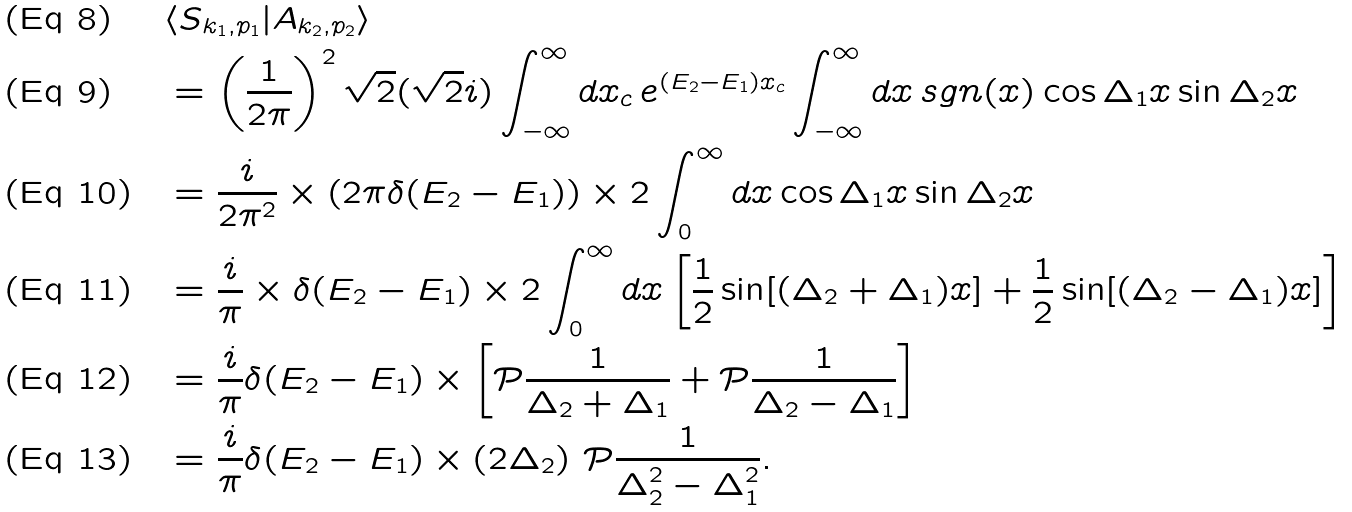Convert formula to latex. <formula><loc_0><loc_0><loc_500><loc_500>& \langle S _ { k _ { 1 } , p _ { 1 } } | A _ { k _ { 2 } , p _ { 2 } } \rangle \\ & = \left ( \frac { 1 } { 2 \pi } \right ) ^ { 2 } \sqrt { 2 } ( \sqrt { 2 } i ) \int _ { - \infty } ^ { \infty } d x _ { c } \, e ^ { ( E _ { 2 } - E _ { 1 } ) x _ { c } } \int _ { - \infty } ^ { \infty } d x \, s g n ( x ) \cos \Delta _ { 1 } x \sin \Delta _ { 2 } x \\ & = \frac { i } { 2 \pi ^ { 2 } } \times \left ( 2 \pi \delta ( E _ { 2 } - E _ { 1 } ) \right ) \times 2 \int _ { 0 } ^ { \infty } d x \cos \Delta _ { 1 } x \sin \Delta _ { 2 } x \\ & = \frac { i } { \pi } \times \delta ( E _ { 2 } - E _ { 1 } ) \times 2 \int _ { 0 } ^ { \infty } d x \left [ \frac { 1 } { 2 } \sin [ ( \Delta _ { 2 } + \Delta _ { 1 } ) x ] + \frac { 1 } { 2 } \sin [ ( \Delta _ { 2 } - \Delta _ { 1 } ) x ] \right ] \\ & = \frac { i } { \pi } \delta ( E _ { 2 } - E _ { 1 } ) \times \left [ \mathcal { P } \frac { 1 } { \Delta _ { 2 } + \Delta _ { 1 } } + \mathcal { P } \frac { 1 } { \Delta _ { 2 } - \Delta _ { 1 } } \right ] \\ & = \frac { i } { \pi } \delta ( E _ { 2 } - E _ { 1 } ) \times \left ( 2 \Delta _ { 2 } \right ) \, \mathcal { P } \frac { 1 } { \Delta _ { 2 } ^ { 2 } - \Delta _ { 1 } ^ { 2 } } .</formula> 